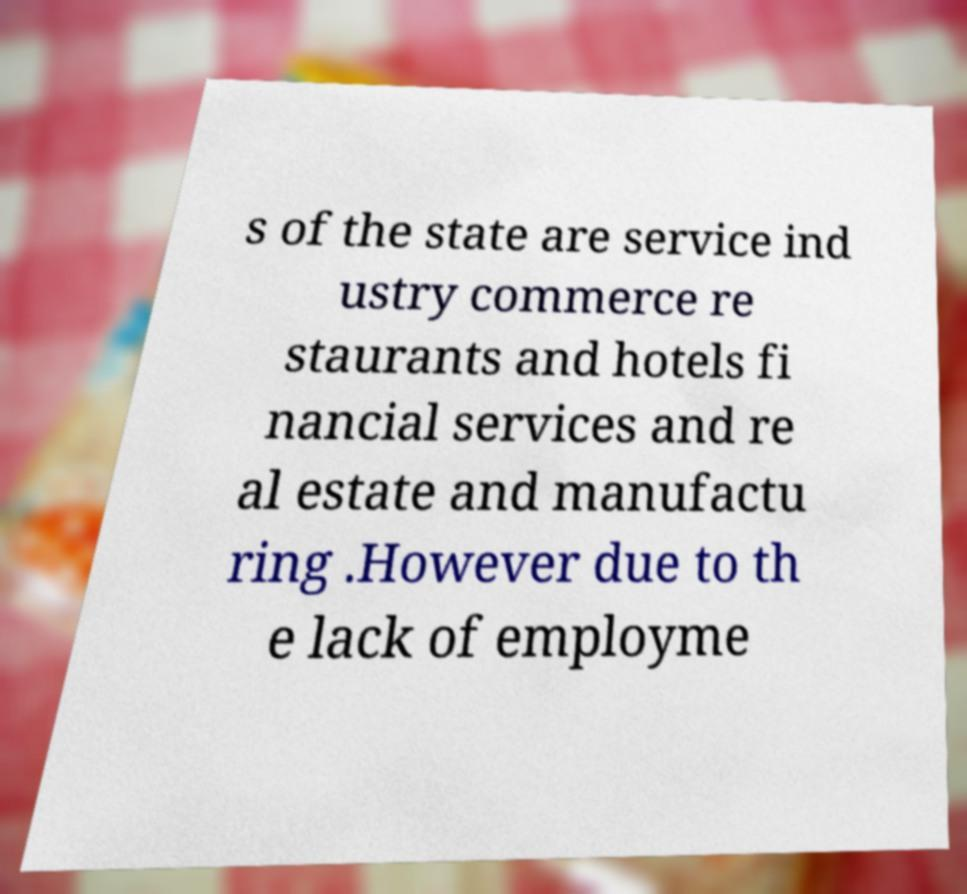Please identify and transcribe the text found in this image. s of the state are service ind ustry commerce re staurants and hotels fi nancial services and re al estate and manufactu ring .However due to th e lack of employme 